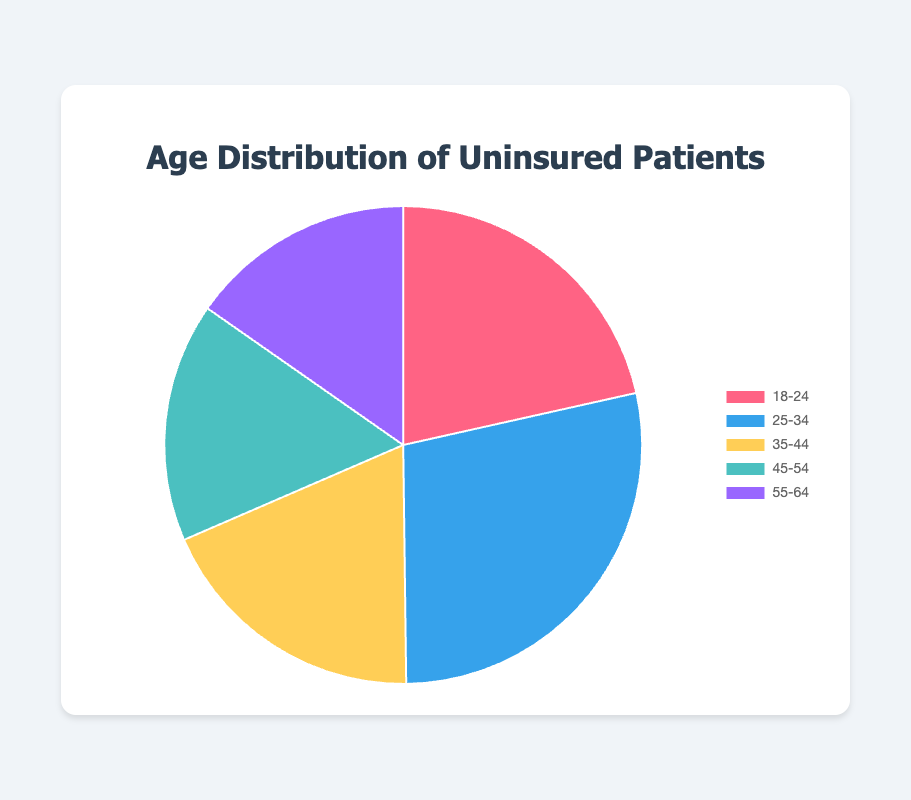What percentage of uninsured patients are aged 25-34? The chart shows that the slice representing the 25-34 age group corresponds to 28.3% of uninsured patients.
Answer: 28.3% Which age group constitutes the smallest proportion of uninsured patients? Among the age groups, the 55-64 group occupies the smallest slice in the pie chart, indicating the least percentage of uninsured patients.
Answer: 55-64 What is the combined percentage of uninsured patients in the age ranges 35-44 and 45-54? The chart shows that the 35-44 age group is 18.7% and the 45-54 age group is 16.2%. Adding them together gives us 18.7% + 16.2% = 34.9%.
Answer: 34.9% Which age group has a larger percentage of uninsured patients, 18-24 or 45-54? The pie chart shows that the 18-24 group has a percentage of 21.5%, while the 45-54 group has 16.2%. Therefore, the 18-24 group has a larger percentage.
Answer: 18-24 What percentage of uninsured patients are aged 55-64 and what color represents this group? The chart shows that 15.3% of uninsured patients are in the 55-64 age range. The corresponding slice is colored purple.
Answer: 15.3%, purple What is the total percentage of uninsured patients for the age groups 18-24 and 25-34? The chart shows the 18-24 age group at 21.5% and the 25-34 age group at 28.3%. Adding these gives us 21.5% + 28.3% = 49.8%.
Answer: 49.8% Which age group has the highest percentage of uninsured patients, and what is that percentage? The chart indicates that the 25-34 age group has the largest slice, representing the highest percentage of 28.3%.
Answer: 25-34, 28.3% How many age groups have a percentage of uninsured patients greater than 20%? By examining the chart, we can see the 18-24 (21.5%) and 25-34 (28.3%) age groups each have a percentage higher than 20%. Thus, there are 2 age groups meeting this criterion.
Answer: 2 What is the percentage difference between the age groups 25-34 and 45-54? The chart shows 28.3% for the 25-34 age group and 16.2% for the 45-54 age group. The percentage difference is 28.3% - 16.2% = 12.1%.
Answer: 12.1% What is the average percentage of uninsured patients for all age groups? Summing the percentages: 21.5% + 28.3% + 18.7% + 16.2% + 15.3% = 100%. Since there are 5 age groups, the average is 100% / 5 = 20%.
Answer: 20% 